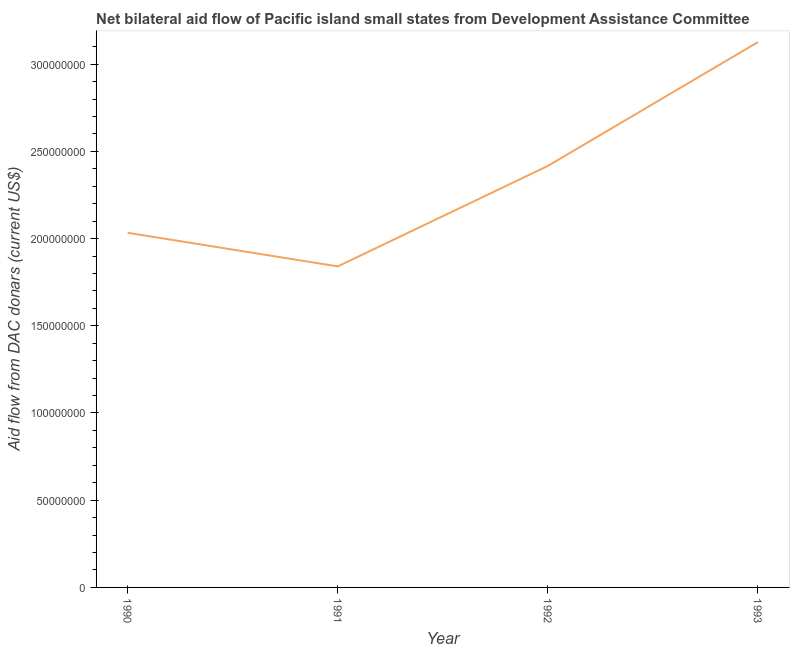What is the net bilateral aid flows from dac donors in 1992?
Your answer should be very brief. 2.42e+08. Across all years, what is the maximum net bilateral aid flows from dac donors?
Provide a succinct answer. 3.13e+08. Across all years, what is the minimum net bilateral aid flows from dac donors?
Your response must be concise. 1.84e+08. In which year was the net bilateral aid flows from dac donors maximum?
Your response must be concise. 1993. What is the sum of the net bilateral aid flows from dac donors?
Your answer should be compact. 9.42e+08. What is the difference between the net bilateral aid flows from dac donors in 1992 and 1993?
Your response must be concise. -7.10e+07. What is the average net bilateral aid flows from dac donors per year?
Provide a short and direct response. 2.35e+08. What is the median net bilateral aid flows from dac donors?
Provide a short and direct response. 2.22e+08. Do a majority of the years between 1990 and 1993 (inclusive) have net bilateral aid flows from dac donors greater than 190000000 US$?
Give a very brief answer. Yes. What is the ratio of the net bilateral aid flows from dac donors in 1991 to that in 1992?
Provide a succinct answer. 0.76. Is the net bilateral aid flows from dac donors in 1990 less than that in 1992?
Give a very brief answer. Yes. Is the difference between the net bilateral aid flows from dac donors in 1991 and 1992 greater than the difference between any two years?
Offer a terse response. No. What is the difference between the highest and the second highest net bilateral aid flows from dac donors?
Offer a very short reply. 7.10e+07. Is the sum of the net bilateral aid flows from dac donors in 1991 and 1993 greater than the maximum net bilateral aid flows from dac donors across all years?
Offer a very short reply. Yes. What is the difference between the highest and the lowest net bilateral aid flows from dac donors?
Keep it short and to the point. 1.29e+08. In how many years, is the net bilateral aid flows from dac donors greater than the average net bilateral aid flows from dac donors taken over all years?
Give a very brief answer. 2. How many years are there in the graph?
Give a very brief answer. 4. What is the difference between two consecutive major ticks on the Y-axis?
Give a very brief answer. 5.00e+07. Are the values on the major ticks of Y-axis written in scientific E-notation?
Ensure brevity in your answer.  No. Does the graph contain grids?
Offer a very short reply. No. What is the title of the graph?
Make the answer very short. Net bilateral aid flow of Pacific island small states from Development Assistance Committee. What is the label or title of the X-axis?
Make the answer very short. Year. What is the label or title of the Y-axis?
Keep it short and to the point. Aid flow from DAC donars (current US$). What is the Aid flow from DAC donars (current US$) in 1990?
Provide a short and direct response. 2.03e+08. What is the Aid flow from DAC donars (current US$) in 1991?
Your response must be concise. 1.84e+08. What is the Aid flow from DAC donars (current US$) in 1992?
Provide a succinct answer. 2.42e+08. What is the Aid flow from DAC donars (current US$) in 1993?
Your answer should be very brief. 3.13e+08. What is the difference between the Aid flow from DAC donars (current US$) in 1990 and 1991?
Keep it short and to the point. 1.93e+07. What is the difference between the Aid flow from DAC donars (current US$) in 1990 and 1992?
Your response must be concise. -3.84e+07. What is the difference between the Aid flow from DAC donars (current US$) in 1990 and 1993?
Provide a short and direct response. -1.09e+08. What is the difference between the Aid flow from DAC donars (current US$) in 1991 and 1992?
Your answer should be very brief. -5.76e+07. What is the difference between the Aid flow from DAC donars (current US$) in 1991 and 1993?
Your answer should be compact. -1.29e+08. What is the difference between the Aid flow from DAC donars (current US$) in 1992 and 1993?
Make the answer very short. -7.10e+07. What is the ratio of the Aid flow from DAC donars (current US$) in 1990 to that in 1991?
Your answer should be very brief. 1.1. What is the ratio of the Aid flow from DAC donars (current US$) in 1990 to that in 1992?
Keep it short and to the point. 0.84. What is the ratio of the Aid flow from DAC donars (current US$) in 1990 to that in 1993?
Provide a succinct answer. 0.65. What is the ratio of the Aid flow from DAC donars (current US$) in 1991 to that in 1992?
Give a very brief answer. 0.76. What is the ratio of the Aid flow from DAC donars (current US$) in 1991 to that in 1993?
Ensure brevity in your answer.  0.59. What is the ratio of the Aid flow from DAC donars (current US$) in 1992 to that in 1993?
Ensure brevity in your answer.  0.77. 